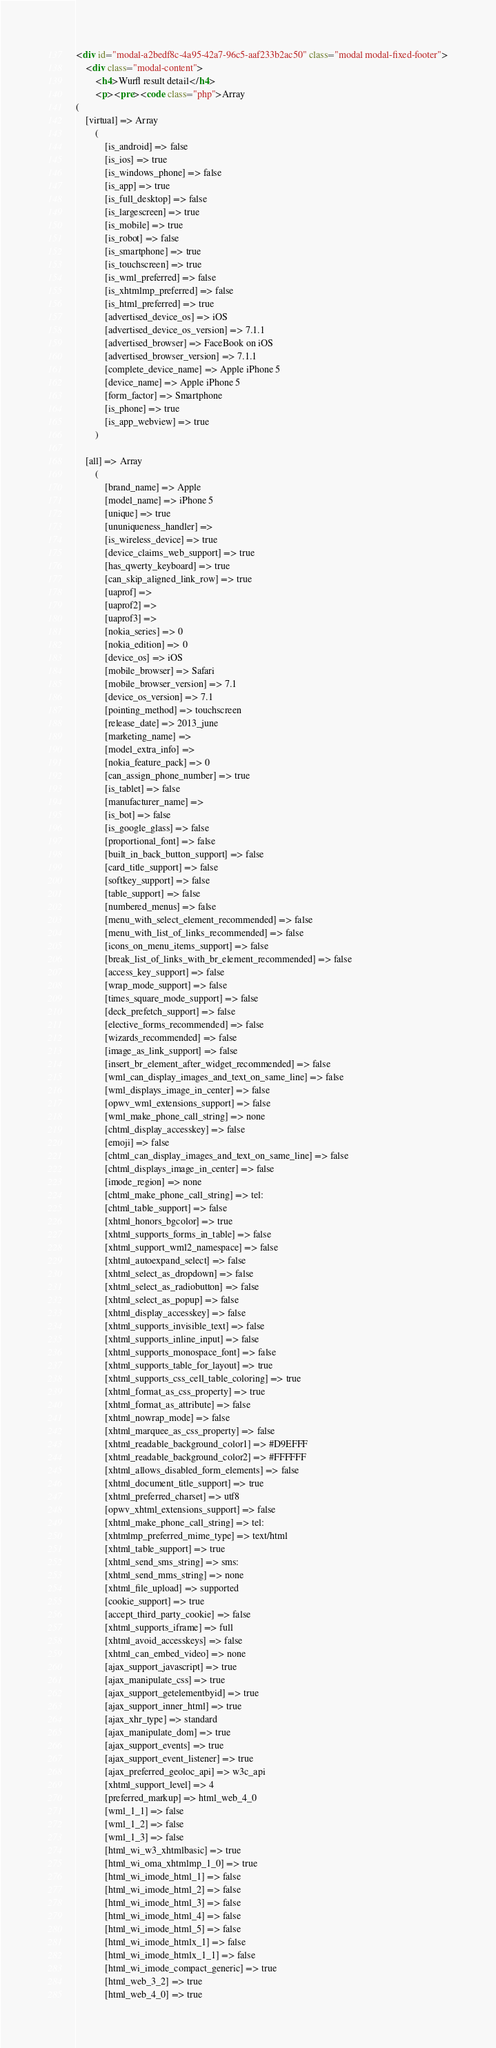<code> <loc_0><loc_0><loc_500><loc_500><_HTML_><div id="modal-a2bedf8c-4a95-42a7-96c5-aaf233b2ac50" class="modal modal-fixed-footer">
    <div class="modal-content">
        <h4>Wurfl result detail</h4>
        <p><pre><code class="php">Array
(
    [virtual] => Array
        (
            [is_android] => false
            [is_ios] => true
            [is_windows_phone] => false
            [is_app] => true
            [is_full_desktop] => false
            [is_largescreen] => true
            [is_mobile] => true
            [is_robot] => false
            [is_smartphone] => true
            [is_touchscreen] => true
            [is_wml_preferred] => false
            [is_xhtmlmp_preferred] => false
            [is_html_preferred] => true
            [advertised_device_os] => iOS
            [advertised_device_os_version] => 7.1.1
            [advertised_browser] => FaceBook on iOS
            [advertised_browser_version] => 7.1.1
            [complete_device_name] => Apple iPhone 5
            [device_name] => Apple iPhone 5
            [form_factor] => Smartphone
            [is_phone] => true
            [is_app_webview] => true
        )

    [all] => Array
        (
            [brand_name] => Apple
            [model_name] => iPhone 5
            [unique] => true
            [ununiqueness_handler] => 
            [is_wireless_device] => true
            [device_claims_web_support] => true
            [has_qwerty_keyboard] => true
            [can_skip_aligned_link_row] => true
            [uaprof] => 
            [uaprof2] => 
            [uaprof3] => 
            [nokia_series] => 0
            [nokia_edition] => 0
            [device_os] => iOS
            [mobile_browser] => Safari
            [mobile_browser_version] => 7.1
            [device_os_version] => 7.1
            [pointing_method] => touchscreen
            [release_date] => 2013_june
            [marketing_name] => 
            [model_extra_info] => 
            [nokia_feature_pack] => 0
            [can_assign_phone_number] => true
            [is_tablet] => false
            [manufacturer_name] => 
            [is_bot] => false
            [is_google_glass] => false
            [proportional_font] => false
            [built_in_back_button_support] => false
            [card_title_support] => false
            [softkey_support] => false
            [table_support] => false
            [numbered_menus] => false
            [menu_with_select_element_recommended] => false
            [menu_with_list_of_links_recommended] => false
            [icons_on_menu_items_support] => false
            [break_list_of_links_with_br_element_recommended] => false
            [access_key_support] => false
            [wrap_mode_support] => false
            [times_square_mode_support] => false
            [deck_prefetch_support] => false
            [elective_forms_recommended] => false
            [wizards_recommended] => false
            [image_as_link_support] => false
            [insert_br_element_after_widget_recommended] => false
            [wml_can_display_images_and_text_on_same_line] => false
            [wml_displays_image_in_center] => false
            [opwv_wml_extensions_support] => false
            [wml_make_phone_call_string] => none
            [chtml_display_accesskey] => false
            [emoji] => false
            [chtml_can_display_images_and_text_on_same_line] => false
            [chtml_displays_image_in_center] => false
            [imode_region] => none
            [chtml_make_phone_call_string] => tel:
            [chtml_table_support] => false
            [xhtml_honors_bgcolor] => true
            [xhtml_supports_forms_in_table] => false
            [xhtml_support_wml2_namespace] => false
            [xhtml_autoexpand_select] => false
            [xhtml_select_as_dropdown] => false
            [xhtml_select_as_radiobutton] => false
            [xhtml_select_as_popup] => false
            [xhtml_display_accesskey] => false
            [xhtml_supports_invisible_text] => false
            [xhtml_supports_inline_input] => false
            [xhtml_supports_monospace_font] => false
            [xhtml_supports_table_for_layout] => true
            [xhtml_supports_css_cell_table_coloring] => true
            [xhtml_format_as_css_property] => true
            [xhtml_format_as_attribute] => false
            [xhtml_nowrap_mode] => false
            [xhtml_marquee_as_css_property] => false
            [xhtml_readable_background_color1] => #D9EFFF
            [xhtml_readable_background_color2] => #FFFFFF
            [xhtml_allows_disabled_form_elements] => false
            [xhtml_document_title_support] => true
            [xhtml_preferred_charset] => utf8
            [opwv_xhtml_extensions_support] => false
            [xhtml_make_phone_call_string] => tel:
            [xhtmlmp_preferred_mime_type] => text/html
            [xhtml_table_support] => true
            [xhtml_send_sms_string] => sms:
            [xhtml_send_mms_string] => none
            [xhtml_file_upload] => supported
            [cookie_support] => true
            [accept_third_party_cookie] => false
            [xhtml_supports_iframe] => full
            [xhtml_avoid_accesskeys] => false
            [xhtml_can_embed_video] => none
            [ajax_support_javascript] => true
            [ajax_manipulate_css] => true
            [ajax_support_getelementbyid] => true
            [ajax_support_inner_html] => true
            [ajax_xhr_type] => standard
            [ajax_manipulate_dom] => true
            [ajax_support_events] => true
            [ajax_support_event_listener] => true
            [ajax_preferred_geoloc_api] => w3c_api
            [xhtml_support_level] => 4
            [preferred_markup] => html_web_4_0
            [wml_1_1] => false
            [wml_1_2] => false
            [wml_1_3] => false
            [html_wi_w3_xhtmlbasic] => true
            [html_wi_oma_xhtmlmp_1_0] => true
            [html_wi_imode_html_1] => false
            [html_wi_imode_html_2] => false
            [html_wi_imode_html_3] => false
            [html_wi_imode_html_4] => false
            [html_wi_imode_html_5] => false
            [html_wi_imode_htmlx_1] => false
            [html_wi_imode_htmlx_1_1] => false
            [html_wi_imode_compact_generic] => true
            [html_web_3_2] => true
            [html_web_4_0] => true</code> 